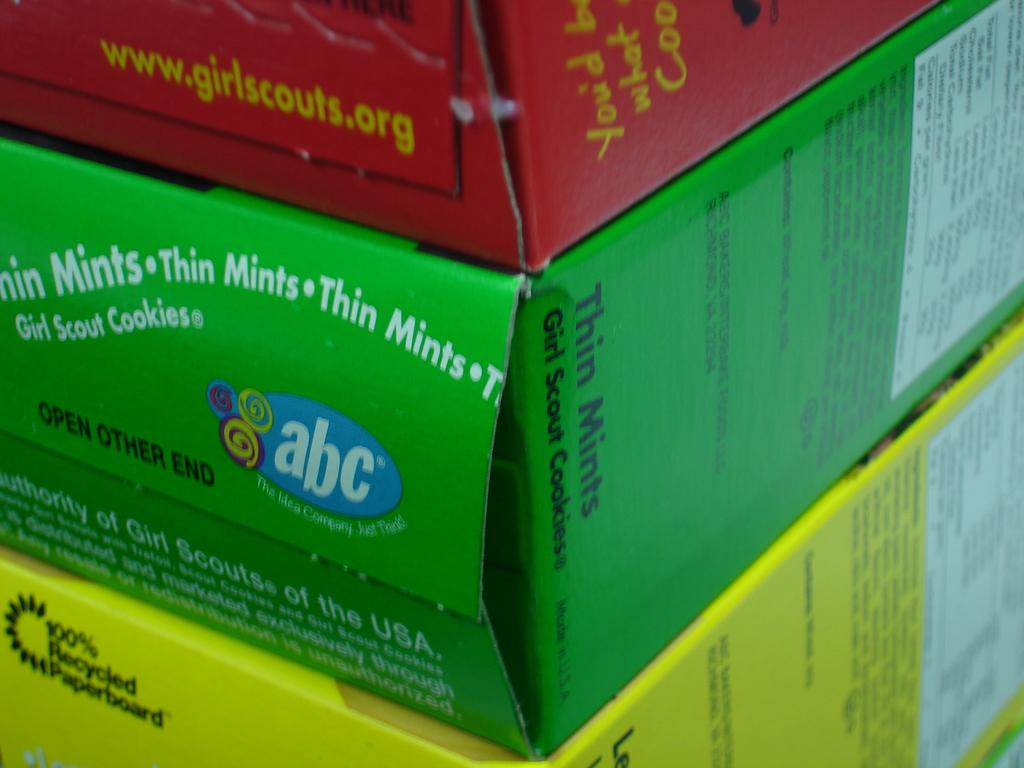Provide a one-sentence caption for the provided image. The sides of several different kinds of Girl Scout cookies. 